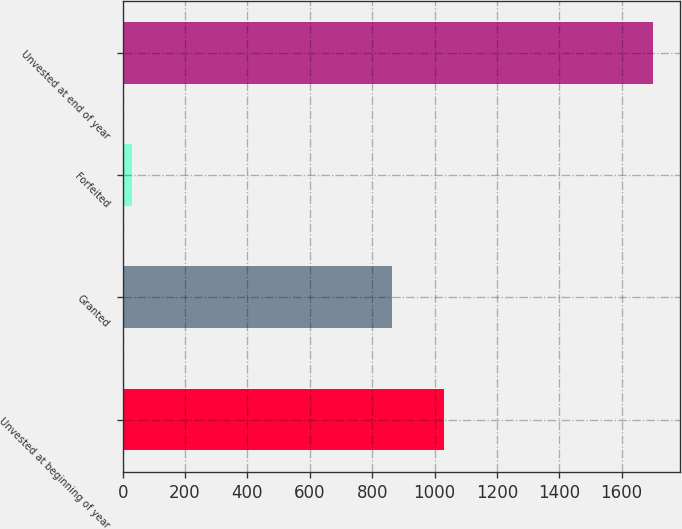<chart> <loc_0><loc_0><loc_500><loc_500><bar_chart><fcel>Unvested at beginning of year<fcel>Granted<fcel>Forfeited<fcel>Unvested at end of year<nl><fcel>1030.2<fcel>863<fcel>29<fcel>1701<nl></chart> 